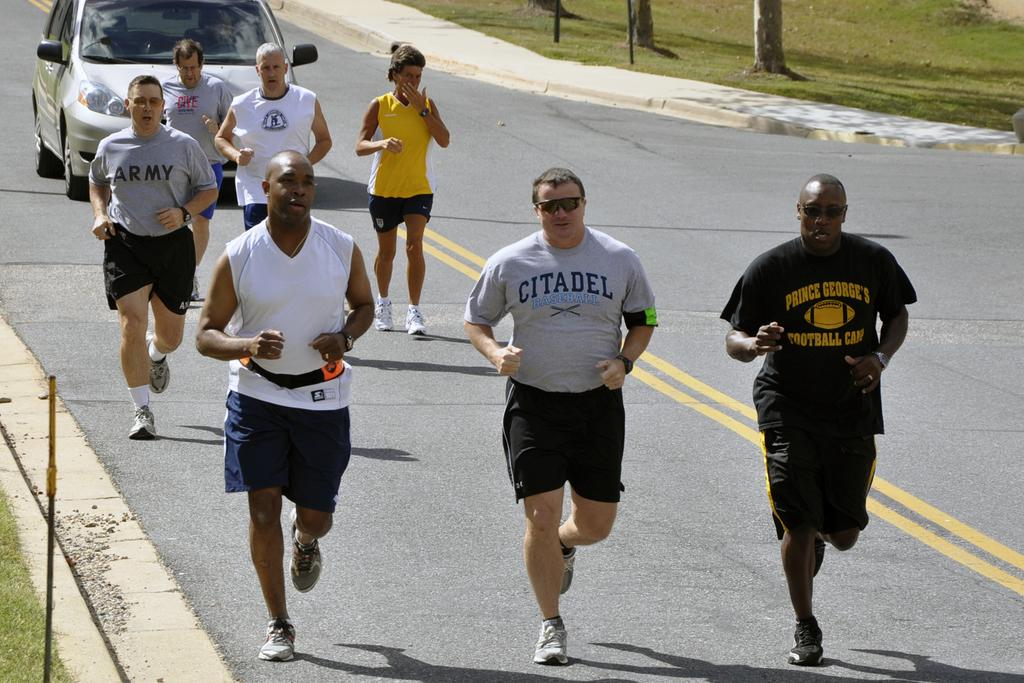What color is the car in the image? The car in the image is white. What else can be seen in the image besides the car? There is a group of people and grass visible in the image. Are there any trees in the image? There are tree stems in the image. What type of glove is being used to apply cream on the car in the image? There is no glove or cream present in the image; it only features a white car, a group of people, grass, and tree stems. 